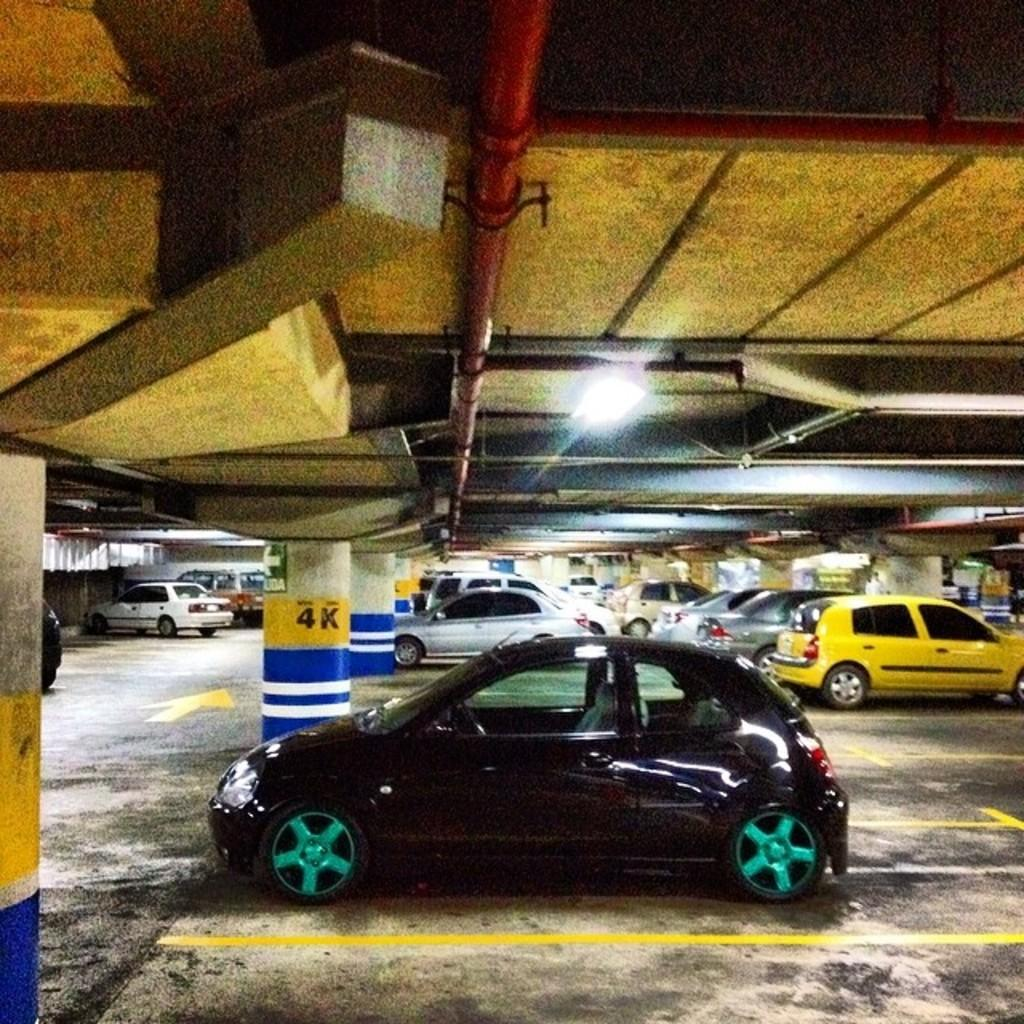<image>
Describe the image concisely. a car that is parked next to the 4K pole 